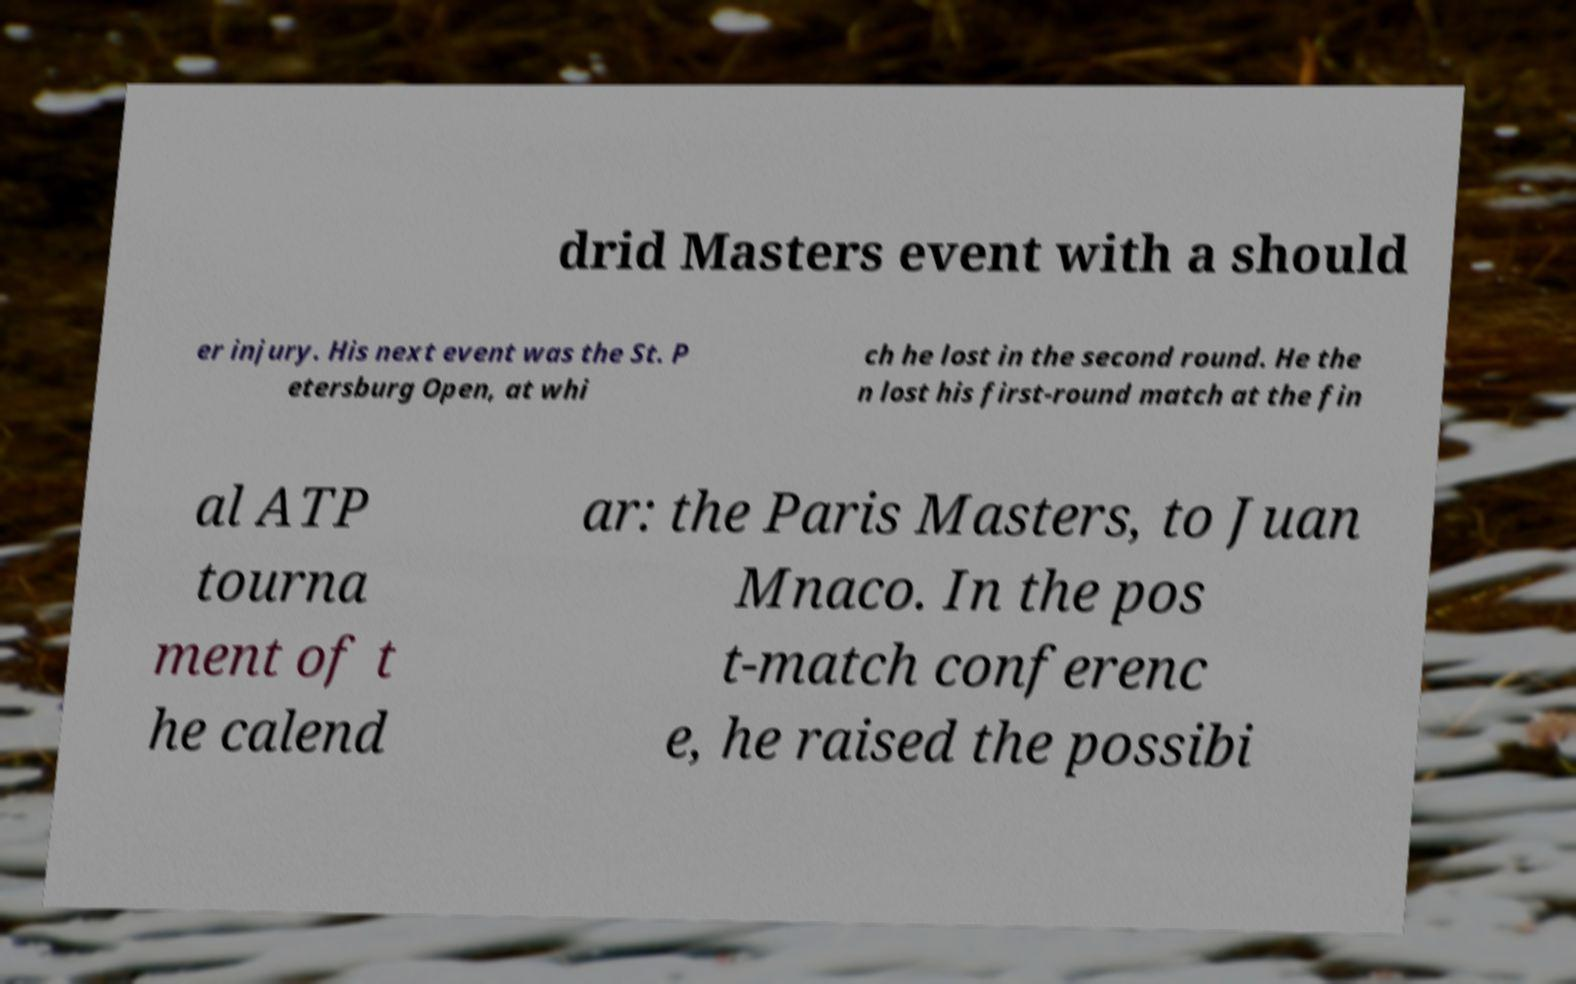Please read and relay the text visible in this image. What does it say? drid Masters event with a should er injury. His next event was the St. P etersburg Open, at whi ch he lost in the second round. He the n lost his first-round match at the fin al ATP tourna ment of t he calend ar: the Paris Masters, to Juan Mnaco. In the pos t-match conferenc e, he raised the possibi 